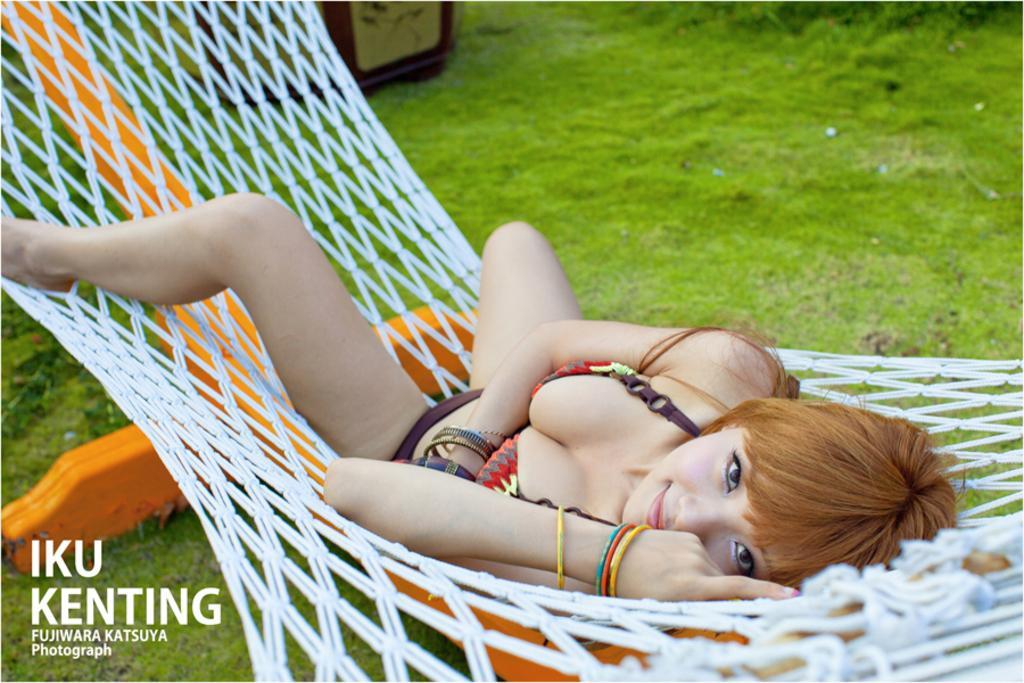Please provide a concise description of this image. In this image, we can see a person lying on the net. We can see the ground covered with some grass and objects. We can also see some text on the bottom left corner. 